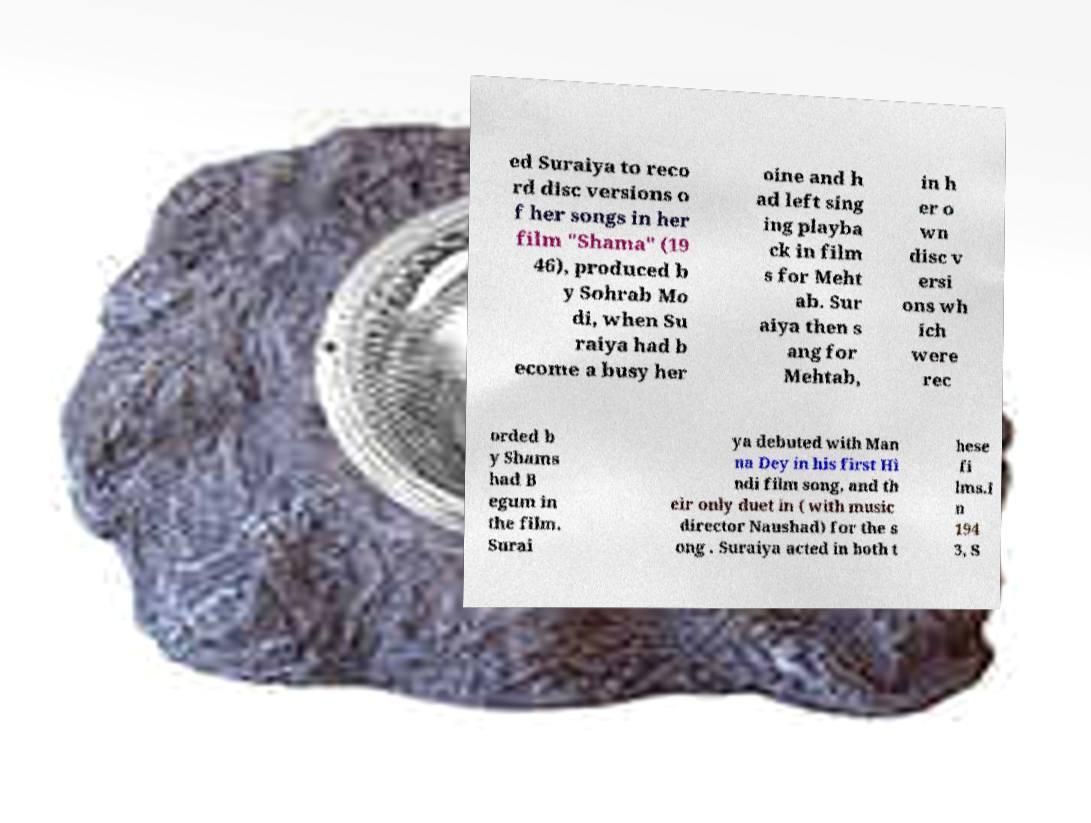Please identify and transcribe the text found in this image. ed Suraiya to reco rd disc versions o f her songs in her film "Shama" (19 46), produced b y Sohrab Mo di, when Su raiya had b ecome a busy her oine and h ad left sing ing playba ck in film s for Meht ab. Sur aiya then s ang for Mehtab, in h er o wn disc v ersi ons wh ich were rec orded b y Shams had B egum in the film. Surai ya debuted with Man na Dey in his first Hi ndi film song, and th eir only duet in ( with music director Naushad) for the s ong . Suraiya acted in both t hese fi lms.I n 194 3, S 